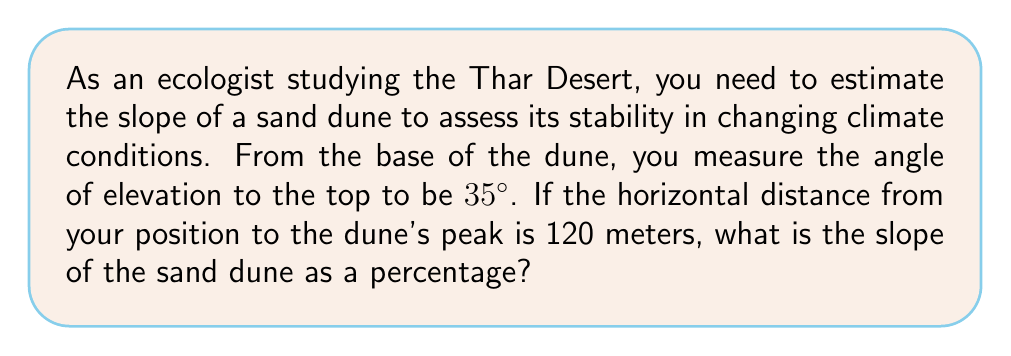Provide a solution to this math problem. Let's approach this step-by-step:

1) First, we need to understand what slope means. Slope is the ratio of vertical rise to horizontal run, often expressed as a percentage.

2) In this problem, we have a right triangle where:
   - The angle of elevation is 35°
   - The horizontal distance (run) is 120 meters
   - We need to find the vertical rise

3) We can use the tangent ratio to find the vertical rise:

   $$ \tan(\theta) = \frac{\text{opposite}}{\text{adjacent}} = \frac{\text{rise}}{\text{run}} $$

4) Plugging in our known values:

   $$ \tan(35°) = \frac{\text{rise}}{120} $$

5) Solve for rise:

   $$ \text{rise} = 120 \cdot \tan(35°) $$

6) Using a calculator:

   $$ \text{rise} \approx 120 \cdot 0.7002 \approx 84.02 \text{ meters} $$

7) Now we have both rise and run, we can calculate the slope as a percentage:

   $$ \text{Slope} = \frac{\text{rise}}{\text{run}} \cdot 100\% $$

8) Plugging in our values:

   $$ \text{Slope} = \frac{84.02}{120} \cdot 100\% \approx 70.02\% $$

Therefore, the slope of the sand dune is approximately 70.02%.
Answer: 70.02% 